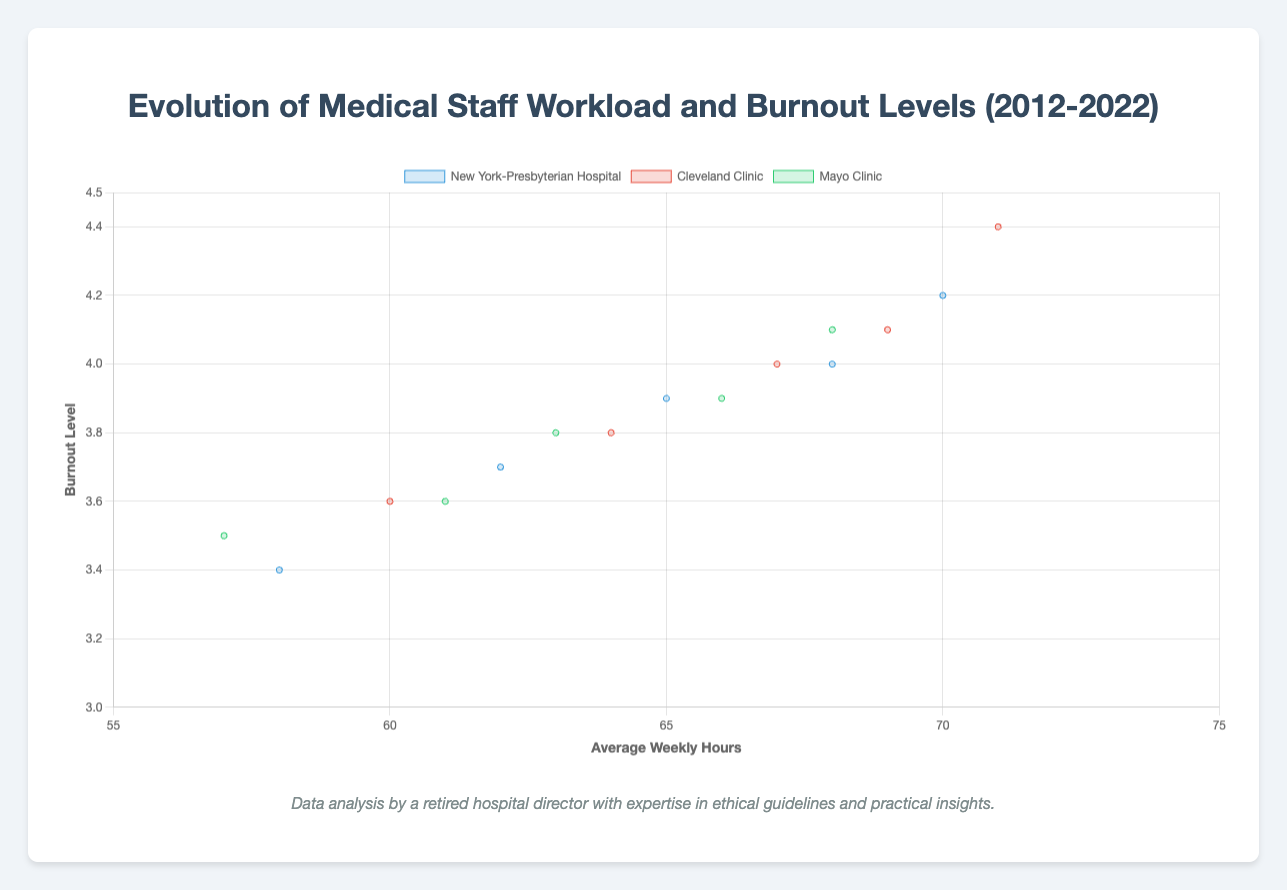What is the average burnout level of medical staff at New York-Presbyterian Hospital in 2022? Observe the data point for New York-Presbyterian Hospital in the year 2022. The burnout level is marked as 4.0 in the figure.
Answer: 4.0 Which hospital had the highest average weekly hours in 2020? Compare the average weekly hours for each hospital in 2020. New York-Presbyterian Hospital had 70 hours, Cleveland Clinic had 71 hours, and Mayo Clinic had 68 hours. Cleveland Clinic had the highest at 71 hours.
Answer: Cleveland Clinic Between 2012 and 2022, which hospital experienced the largest increase in average weekly hours? Calculate the difference in average weekly hours between 2012 and 2022 for each hospital. For New York-Presbyterian Hospital: 68-58=10 hours, Cleveland Clinic: 69-60=9 hours, Mayo Clinic: 66-57=9 hours. New York-Presbyterian Hospital experienced the largest increase.
Answer: New York-Presbyterian Hospital How did the burnout level for Mayo Clinic change between 2018 and 2022? Compare the burnout levels for Mayo Clinic between the years 2018 and 2022. In 2018, the burnout level was 3.8, and in 2022, it was 3.9. The burnout level increased by 0.1.
Answer: Increased by 0.1 Which hospital had the highest burnout level in 2020? Look at the burnout levels for each hospital in 2020. New York-Presbyterian Hospital had 4.2, Cleveland Clinic had 4.4, and Mayo Clinic had 4.1. Cleveland Clinic had the highest burnout level at 4.4.
Answer: Cleveland Clinic What is the overall trend in burnout levels for Cleveland Clinic from 2012 to 2022? Observe the burnout level data points for Cleveland Clinic across the years: 2012 (3.6), 2015 (3.8), 2018 (4.0), 2020 (4.4), and 2022 (4.1). The trend shows a general increase from 2012 to 2020 followed by a slight decrease in 2022.
Answer: Increasing then slightly decreasing What is the combined burnout level for all hospitals in 2020? Sum the burnout levels of all hospitals in 2020: New York-Presbyterian Hospital (4.2), Cleveland Clinic (4.4), Mayo Clinic (4.1). The combined burnout level is 4.2 + 4.4 + 4.1 = 12.7.
Answer: 12.7 Which year did New York-Presbyterian Hospital have a burnout level of 3.9? Find the data point where New York-Presbyterian Hospital has a burnout level of 3.9. This occurs in the year 2018.
Answer: 2018 Comparing 2015 and 2020, which hospital had a larger increase in burnout level: New York-Presbyterian Hospital or Mayo Clinic? Calculate the difference in burnout levels from 2015 to 2020 for both hospitals. For New York-Presbyterian Hospital: 4.2 - 3.7 = 0.5, for Mayo Clinic: 4.1 - 3.6 = 0.5. Both hospitals had the same increase in burnout level (0.5).
Answer: Both had the same increase How does the burnout level for Cleveland Clinic in 2018 compare to the average burnout level of Mayo Clinic in the same year? The burnout level for Cleveland Clinic in 2018 is 4.0. For Mayo Clinic, the burnout level in 2018 is 3.8. Comparing these, Cleveland Clinic's burnout level is higher by 0.2.
Answer: Cleveland Clinic had a higher burnout level by 0.2 